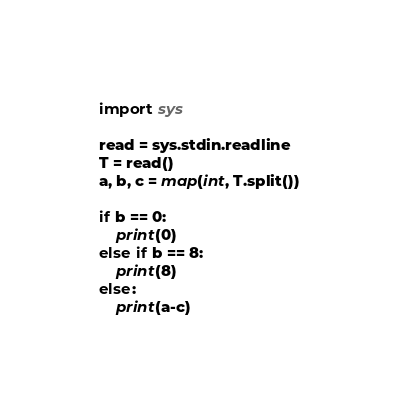Convert code to text. <code><loc_0><loc_0><loc_500><loc_500><_Python_>import sys

read = sys.stdin.readline
T = read()
a, b, c = map(int, T.split())

if b == 0:
    print(0)
else if b == 8:
    print(8)
else:
    print(a-c)</code> 